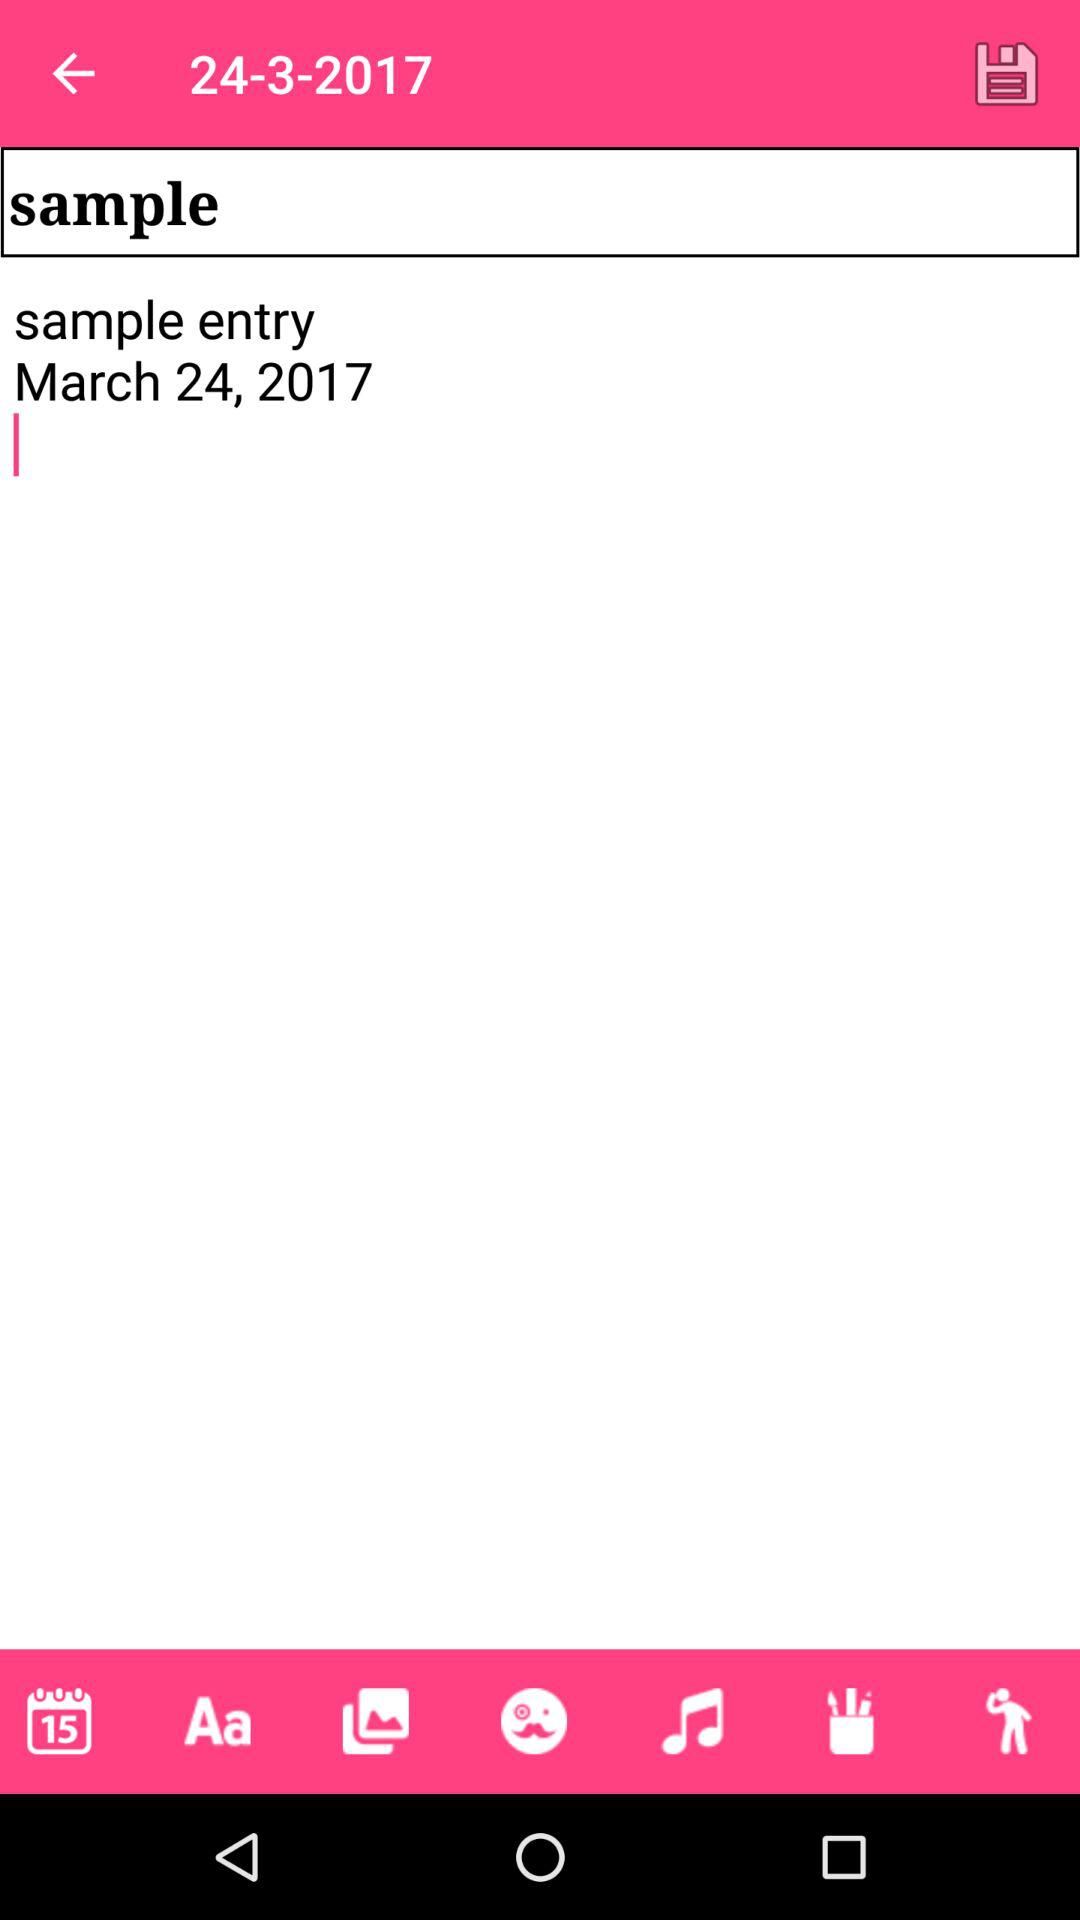What is the sample entry date? The sample entry date is March 24, 2017. 